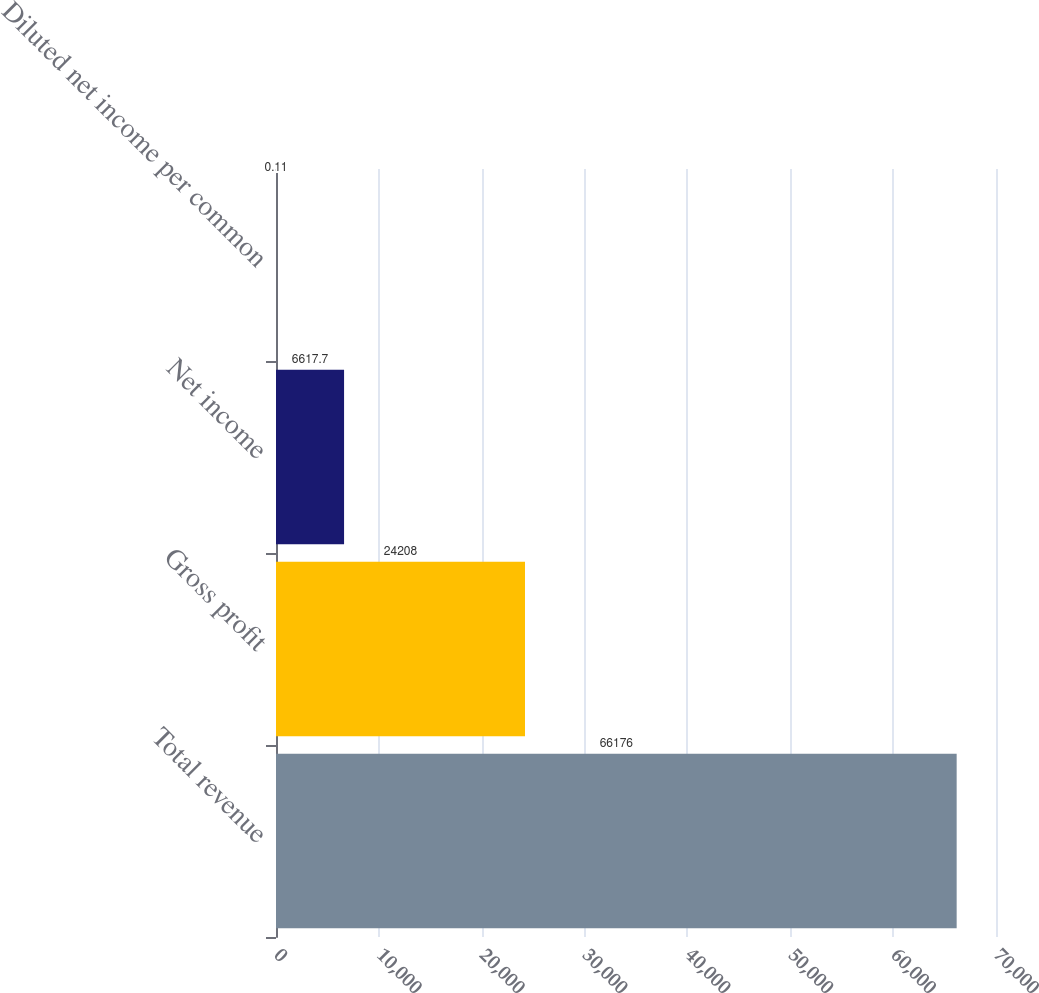<chart> <loc_0><loc_0><loc_500><loc_500><bar_chart><fcel>Total revenue<fcel>Gross profit<fcel>Net income<fcel>Diluted net income per common<nl><fcel>66176<fcel>24208<fcel>6617.7<fcel>0.11<nl></chart> 